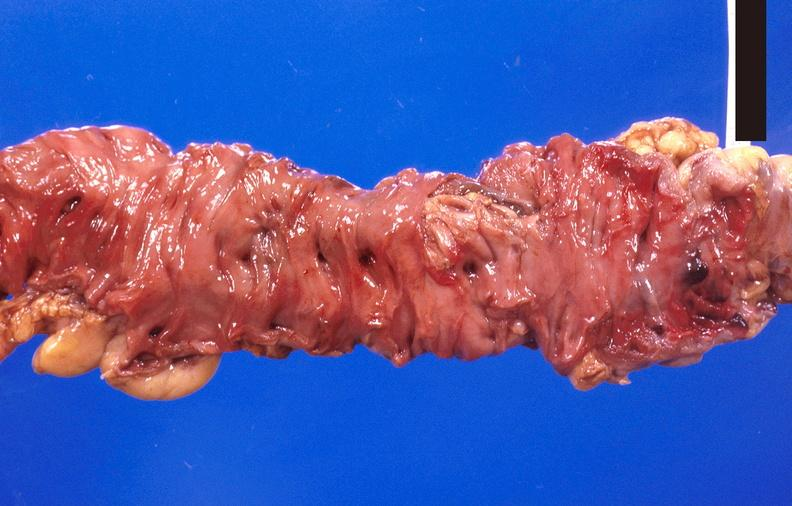s very good example present?
Answer the question using a single word or phrase. No 